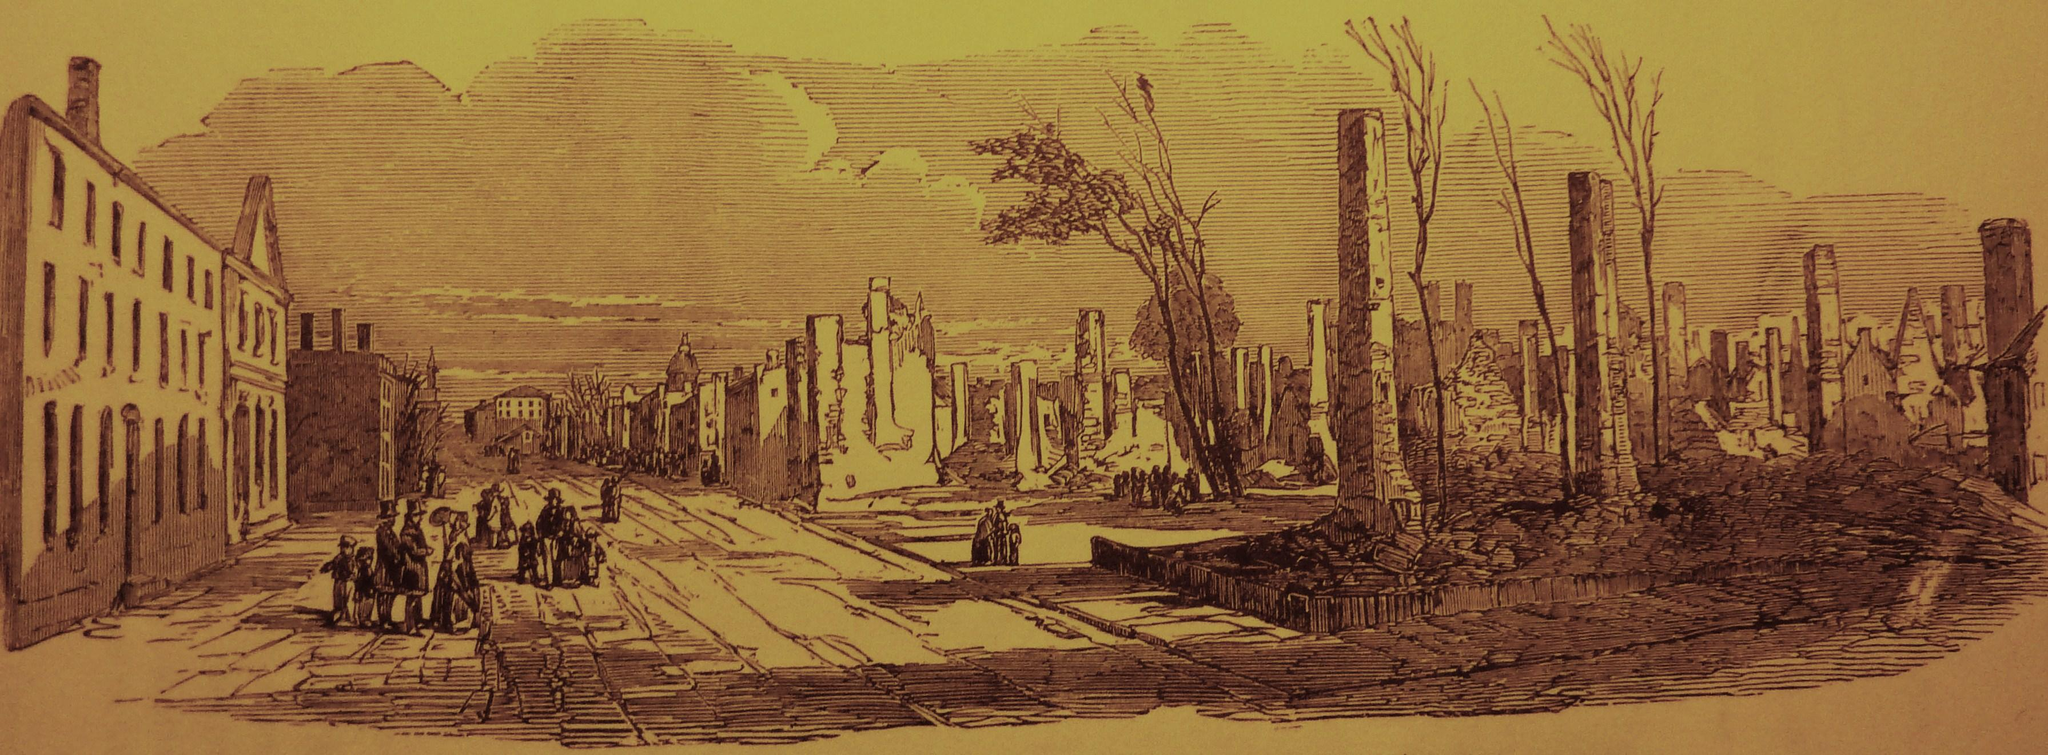What type of artwork is depicted in the image? The image is a painting. What structures can be seen in the painting? There are buildings in the painting. What type of vegetation is present in the painting? There are trees in the painting. Where are the people located in the painting? The people are on the left side of the painting. What is visible at the top of the painting? The sky is visible at the top of the painting. What type of cloth is draped over the hole in the painting? There is no hole or cloth present in the painting; it features buildings, trees, people, and a sky. 